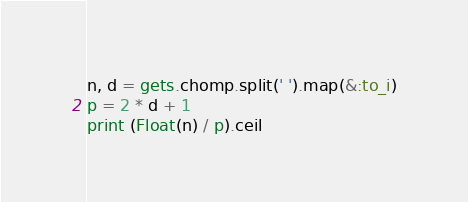<code> <loc_0><loc_0><loc_500><loc_500><_Ruby_>n, d = gets.chomp.split(' ').map(&:to_i)
p = 2 * d + 1
print (Float(n) / p).ceil
</code> 